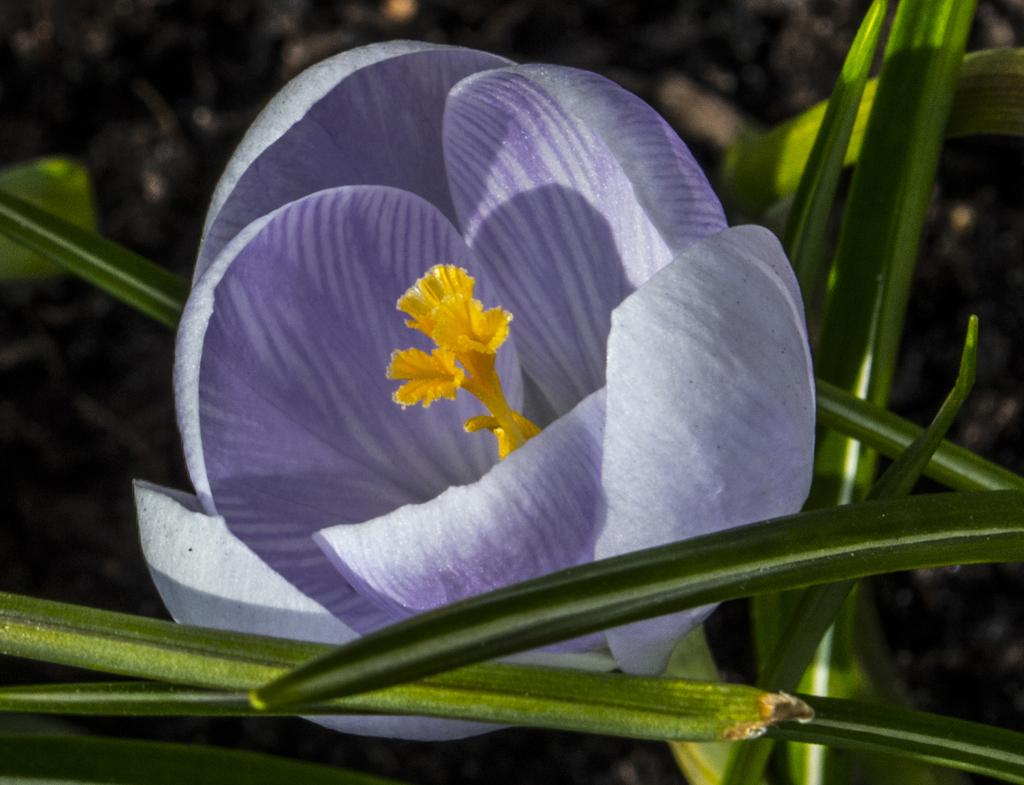What type of flower is in the image? There is a light purple color flower in the image. Where is the flower located? The flower is on a plant. What can be seen in the background of the image? There appears to be mud in the background of the image. How many fish can be seen swimming in the mud in the image? There are no fish present in the image, and the mud is not depicted as containing water for fish to swim in. 